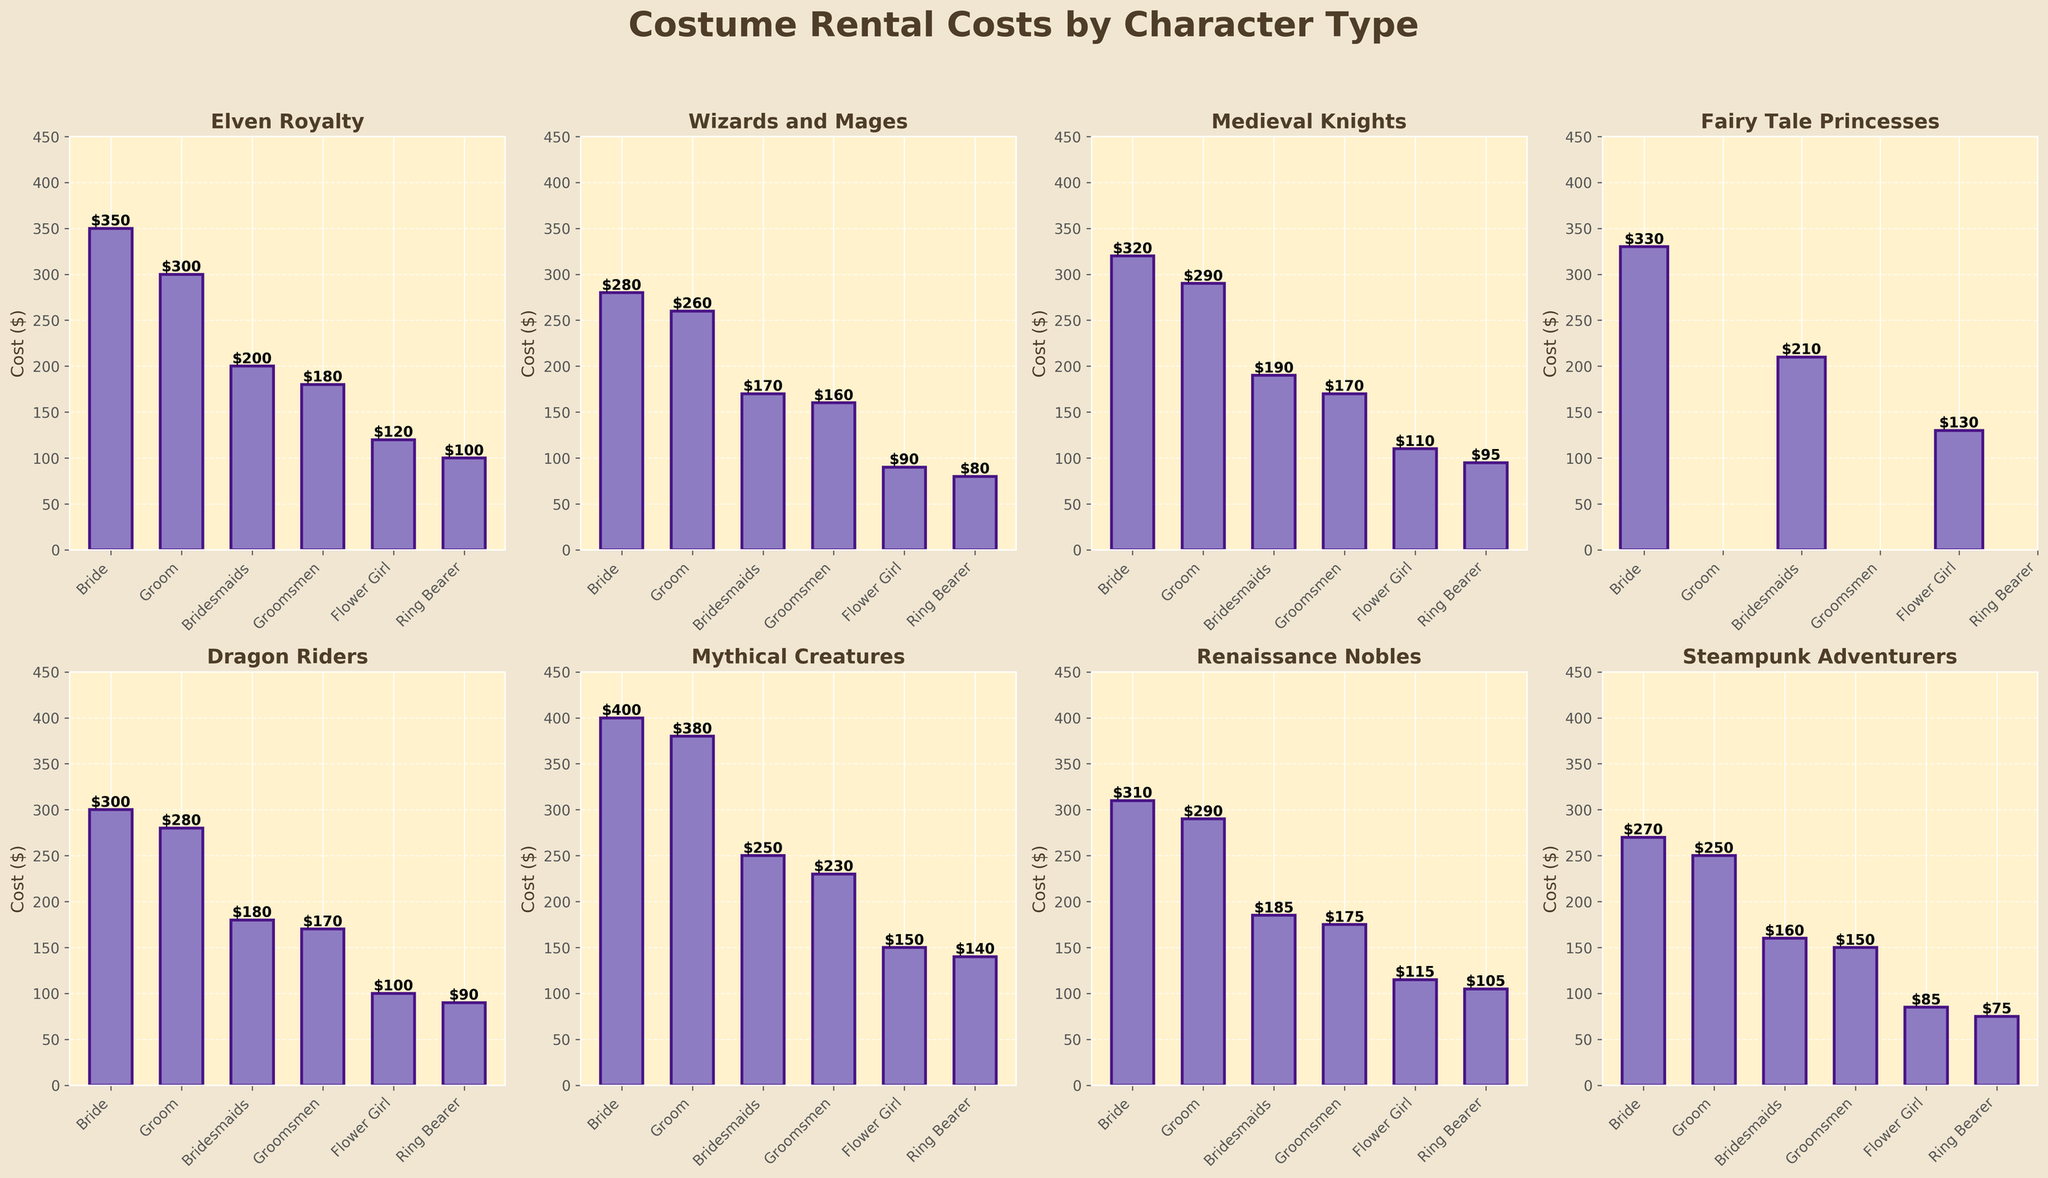What is the title of the figure? The title is situated at the top of the figure and typically describes the content.
Answer: Costume Rental Costs by Character Type What are the two roles that are not available for 'Fairy Tale Princesses'? By looking at the bars for 'Fairy Tale Princesses', there are no bars for Groom and Groomsmen, indicating these are N/A.
Answer: Groom, Groomsmen Which character type has the highest rental cost for the bride's costume? The bar chart for each character type indicates the costs. Among all character types, 'Mythical Creatures' has the tallest bar for the bride.
Answer: Mythical Creatures What is the difference in the rental cost of the bride's costume between 'Elven Royalty' and 'Medieval Knights'? Find the bar heights for 'Elven Royalty' (350) and 'Medieval Knights' (320) for the bride, then subtract the latter from the former.
Answer: 30 Which character type features the lowest rental cost for the ring bearer? Compare the heights of all bars for the ring bearer across all character types; 'Steampunk Adventurers' has the shortest bar.
Answer: Steampunk Adventurers What is the total rental cost for all specified roles in 'Wizards and Mages'? Sum all the bar heights for 'Wizards and Mages' (280 for Bride + 260 for Groom + 170 for Bridesmaids + 160 for Groomsmen + 90 for Flower Girl + 80 for Ring Bearer).
Answer: 1040 How much more does it cost to rent a flower girl's costume as 'Fairy Tale Princesses' compared to 'Elven Royalty'? The flower girl costumes cost 130 for 'Fairy Tale Princesses' and 120 for 'Elven Royalty'. Subtract 120 from 130.
Answer: 10 Which role has the widest range of costume rental costs across all character types? Identify the max and min costs for each role and calculate the difference; The widest range observed is for the Bride (400 - 270 = 130).
Answer: Bride What is the average rental cost for bridesmaids across all character types? Add all the bridesmaid costs (200, 170, 190, 210, 180, 250, 185, 160) and divide by the number of character types (8). ((200+170+190+210+180+250+185+160) / 8).
Answer: 193.125 